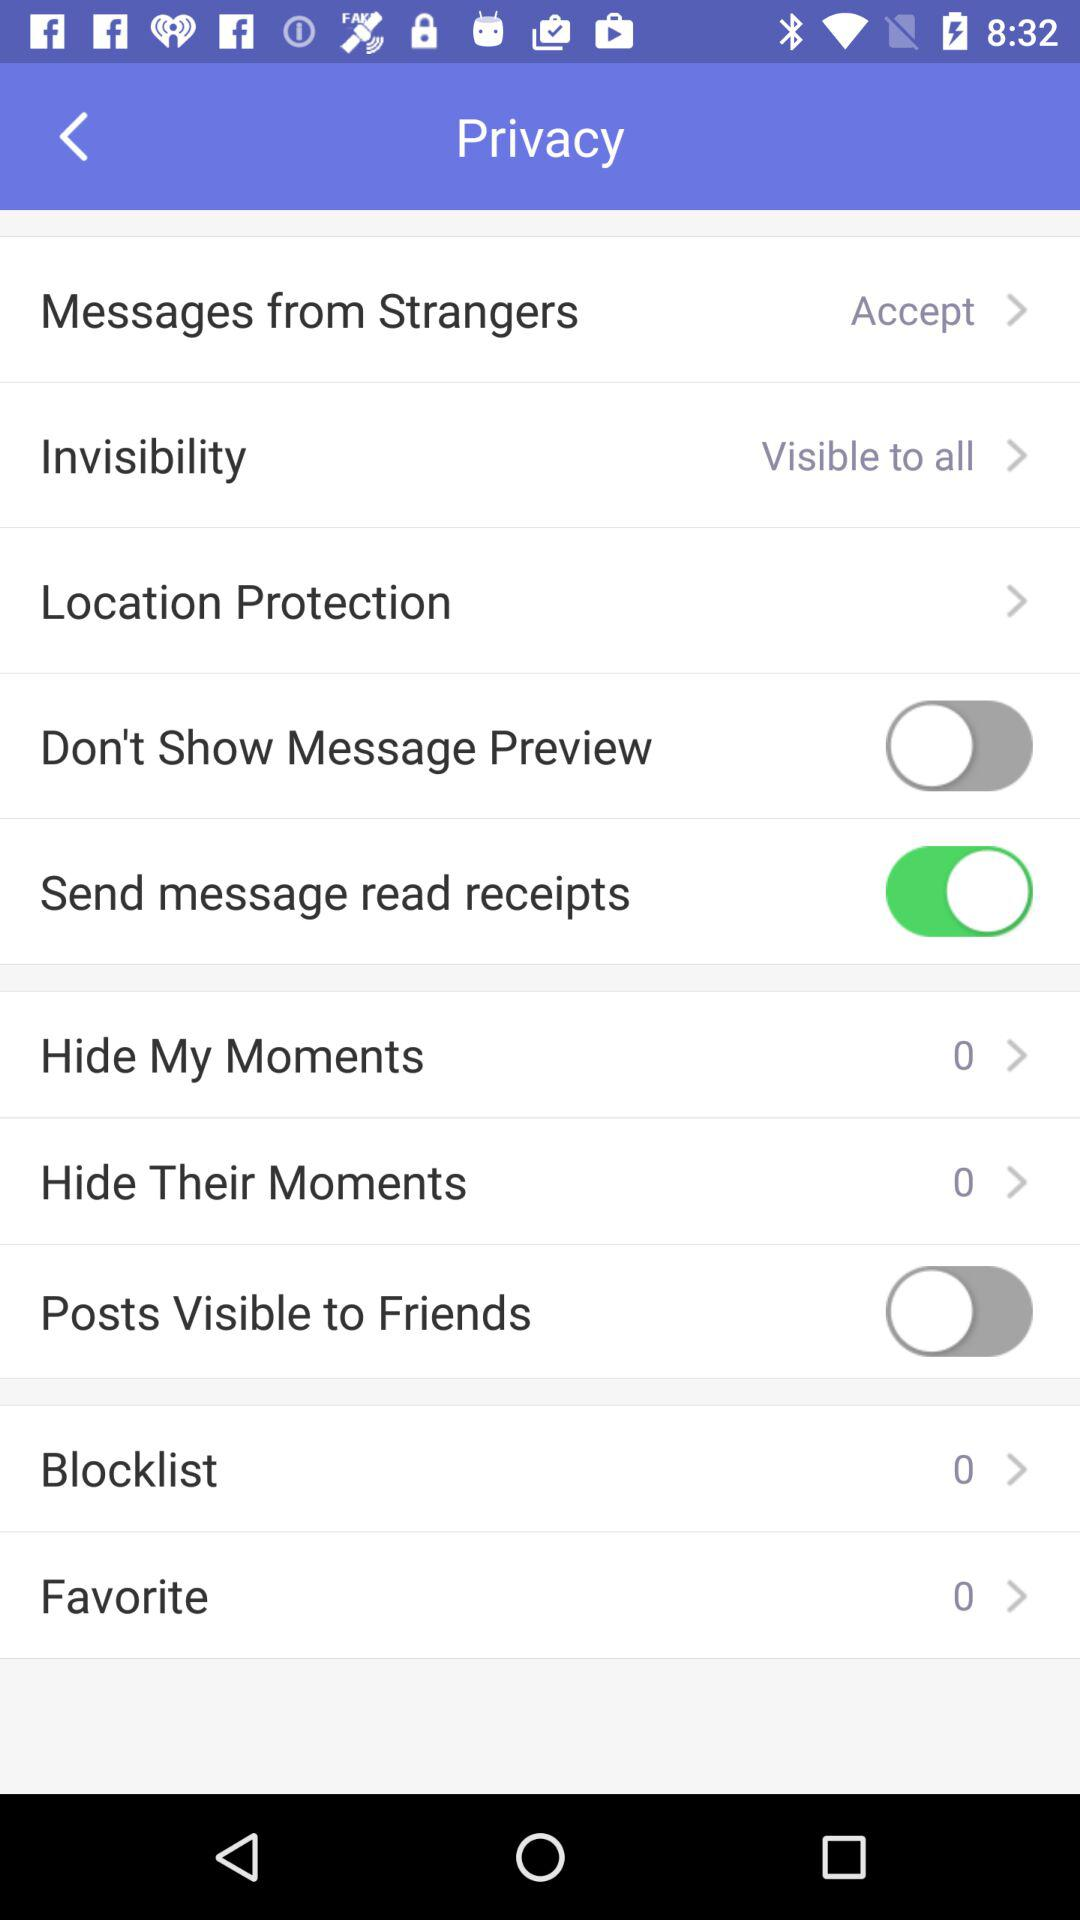What is the count for "Favorite"? The count for "Favorite" is 0. 